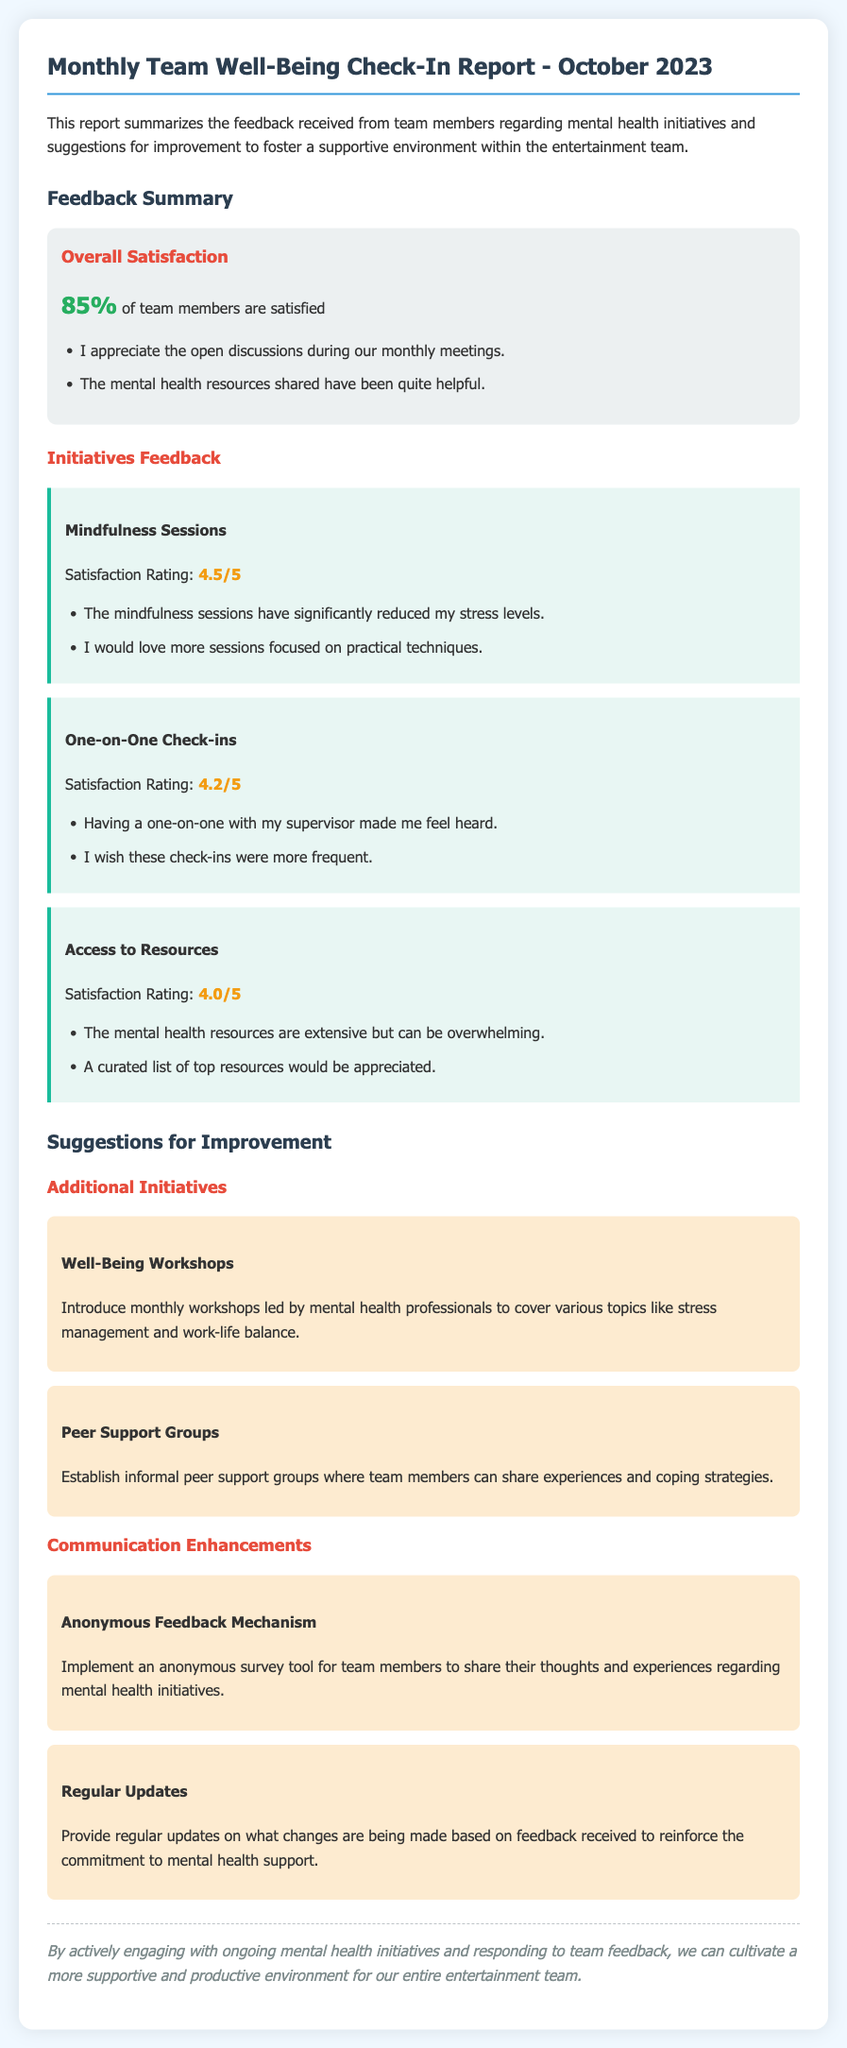What is the overall satisfaction percentage of team members? The overall satisfaction percentage is stated in the report as 85%.
Answer: 85% What is the satisfaction rating for Mindfulness Sessions? The satisfaction rating for Mindfulness Sessions is provided in the report as 4.5/5.
Answer: 4.5/5 How many suggestions for improvement are listed in the report? The report lists four specific suggestions for improvement.
Answer: Four What type of groups are suggested to be established for peer support? The report suggests the establishment of informal peer support groups.
Answer: Informal peer support groups What is one initiative proposed to enhance communication? The report proposes implementing an anonymous survey tool for feedback.
Answer: Anonymous feedback mechanism What resource feedback did team members provide regarding access to resources? The feedback indicated that the mental health resources are extensive but can be overwhelming.
Answer: Extensive but overwhelming What did team members express a desire for more of regarding one-on-one check-ins? Team members expressed a wish for these check-ins to be more frequent.
Answer: More frequent What is the focus of the proposed well-being workshops? The focus of the workshops is on topics like stress management and work-life balance.
Answer: Stress management and work-life balance 